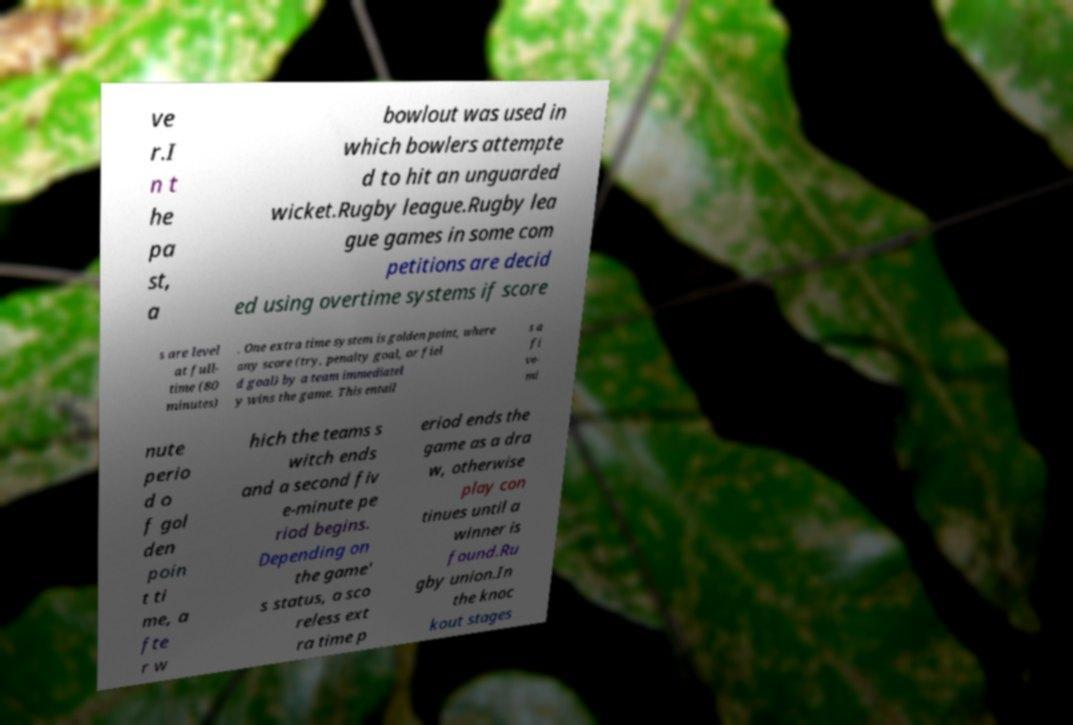Could you assist in decoding the text presented in this image and type it out clearly? ve r.I n t he pa st, a bowlout was used in which bowlers attempte d to hit an unguarded wicket.Rugby league.Rugby lea gue games in some com petitions are decid ed using overtime systems if score s are level at full- time (80 minutes) . One extra time system is golden point, where any score (try, penalty goal, or fiel d goal) by a team immediatel y wins the game. This entail s a fi ve- mi nute perio d o f gol den poin t ti me, a fte r w hich the teams s witch ends and a second fiv e-minute pe riod begins. Depending on the game' s status, a sco reless ext ra time p eriod ends the game as a dra w, otherwise play con tinues until a winner is found.Ru gby union.In the knoc kout stages 